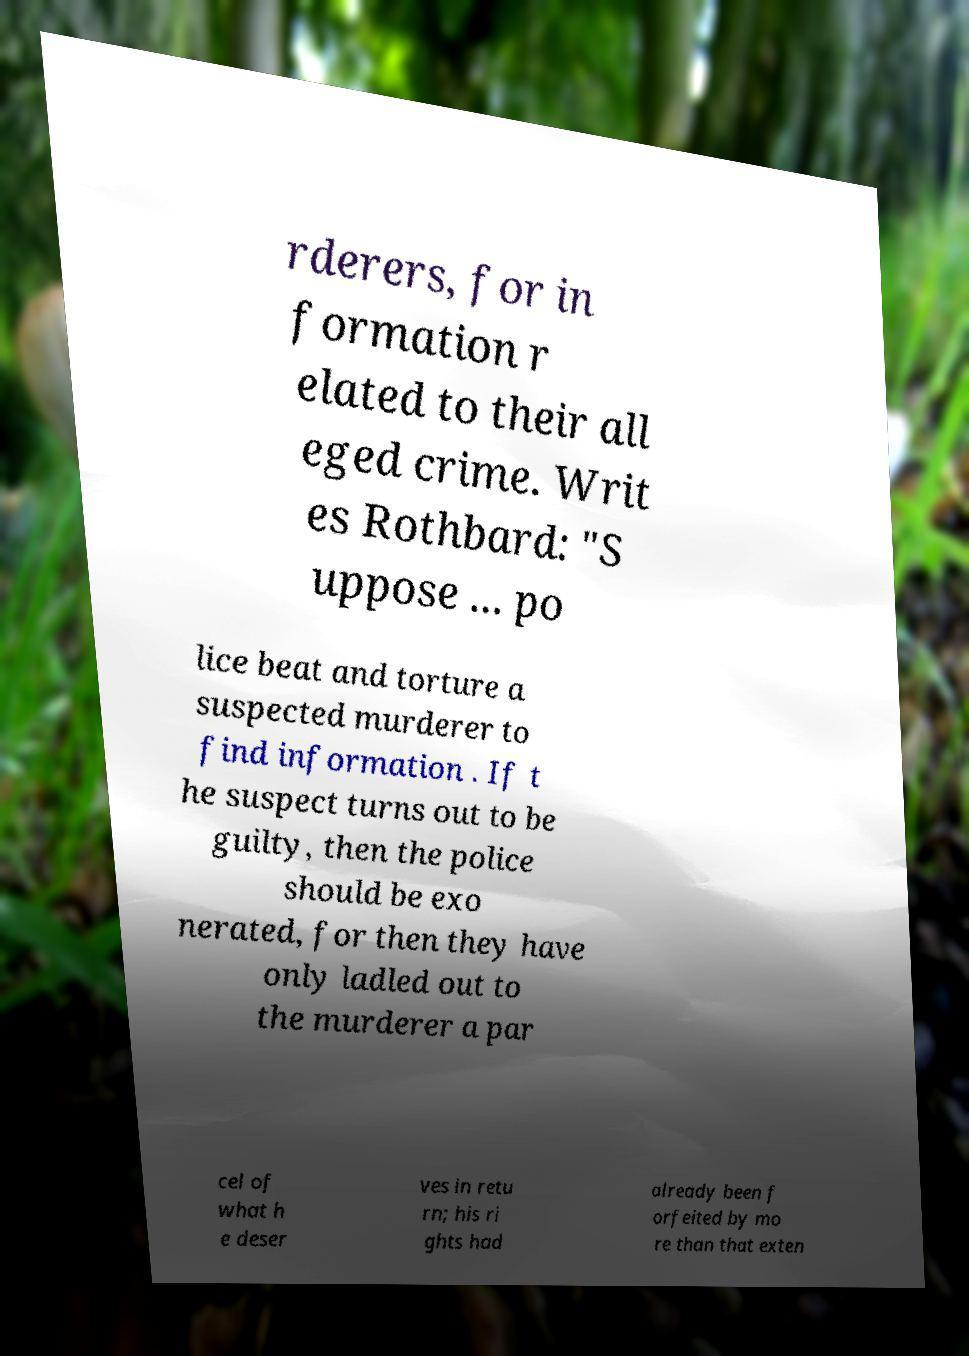I need the written content from this picture converted into text. Can you do that? rderers, for in formation r elated to their all eged crime. Writ es Rothbard: "S uppose ... po lice beat and torture a suspected murderer to find information . If t he suspect turns out to be guilty, then the police should be exo nerated, for then they have only ladled out to the murderer a par cel of what h e deser ves in retu rn; his ri ghts had already been f orfeited by mo re than that exten 